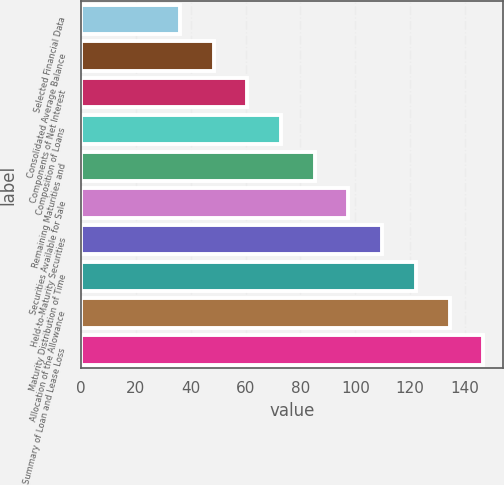Convert chart. <chart><loc_0><loc_0><loc_500><loc_500><bar_chart><fcel>Selected Financial Data<fcel>Consolidated Average Balance<fcel>Components of Net Interest<fcel>Composition of Loans<fcel>Remaining Maturities and<fcel>Securities Available for Sale<fcel>Held-to-Maturity Securities<fcel>Maturity Distribution of Time<fcel>Allocation of the Allowance<fcel>Summary of Loan and Lease Loss<nl><fcel>36<fcel>48.3<fcel>60.6<fcel>72.9<fcel>85.2<fcel>97.5<fcel>109.8<fcel>122.1<fcel>134.4<fcel>146.7<nl></chart> 